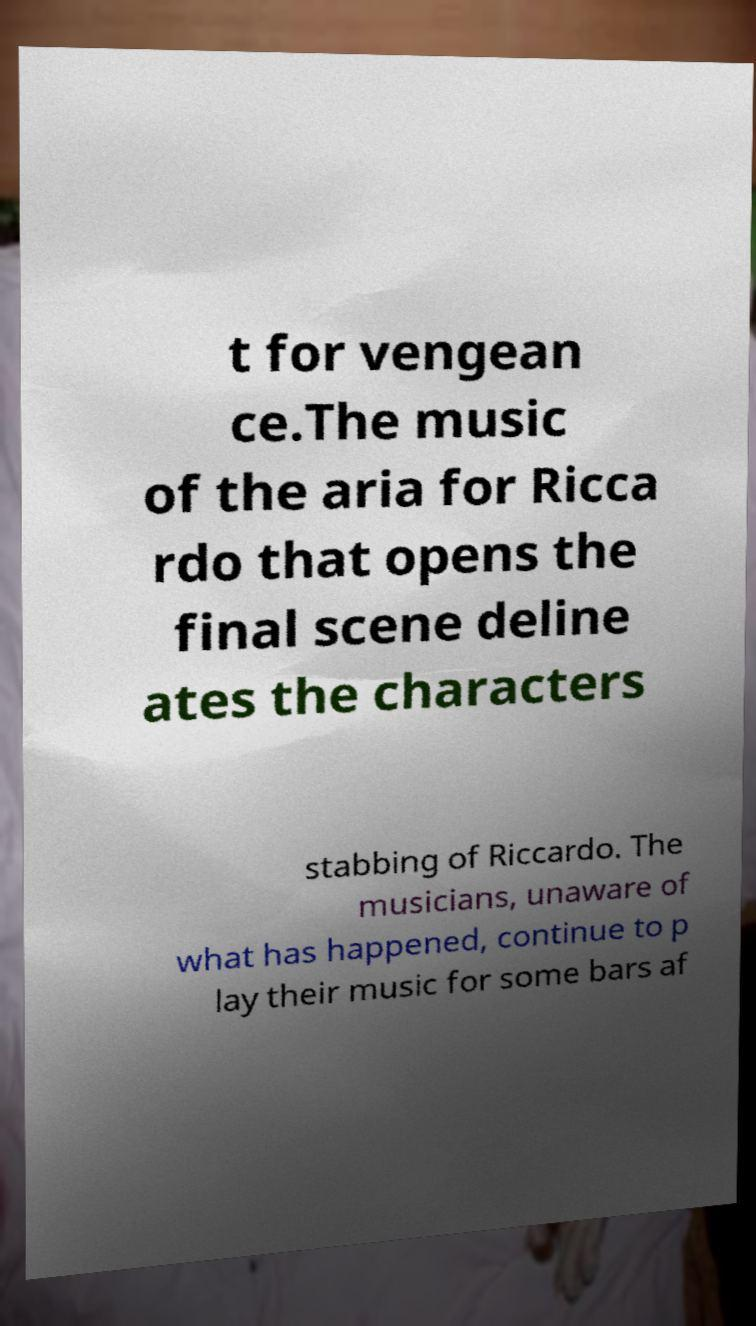For documentation purposes, I need the text within this image transcribed. Could you provide that? t for vengean ce.The music of the aria for Ricca rdo that opens the final scene deline ates the characters stabbing of Riccardo. The musicians, unaware of what has happened, continue to p lay their music for some bars af 